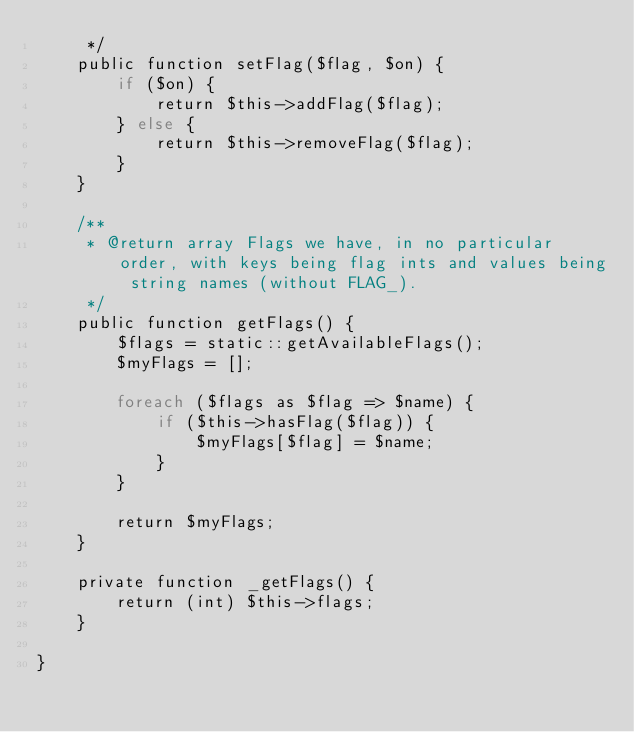<code> <loc_0><loc_0><loc_500><loc_500><_PHP_>     */
    public function setFlag($flag, $on) {
        if ($on) {
            return $this->addFlag($flag);
        } else {
            return $this->removeFlag($flag);
        }
    }

    /**
     * @return array Flags we have, in no particular order, with keys being flag ints and values being string names (without FLAG_).
     */
    public function getFlags() {
        $flags = static::getAvailableFlags();
        $myFlags = [];

        foreach ($flags as $flag => $name) {
            if ($this->hasFlag($flag)) {
                $myFlags[$flag] = $name;
            }
        }

        return $myFlags;
    }

    private function _getFlags() {
        return (int) $this->flags;
    }

}
</code> 